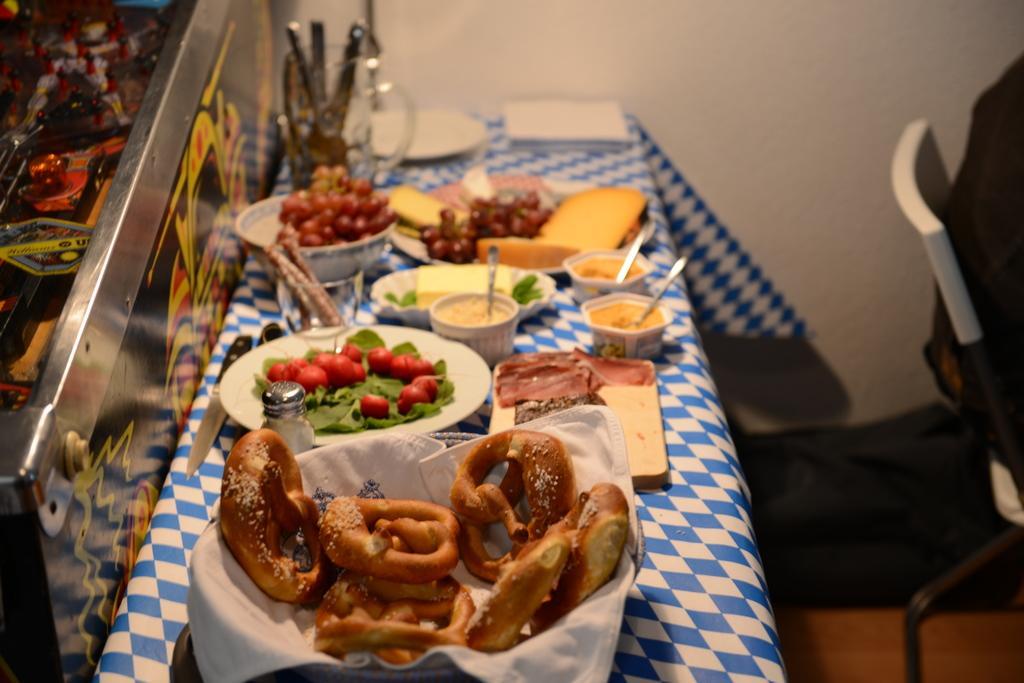Can you describe this image briefly? In the background we can see the wall. On the right side of the picture we can see the partial part of a chair. In this picture we can see objects. We can see a cloth on a platform. We can see On the platform we can see food, plates, bowls, spoons and few objects. We can see objects in a glass holder. 